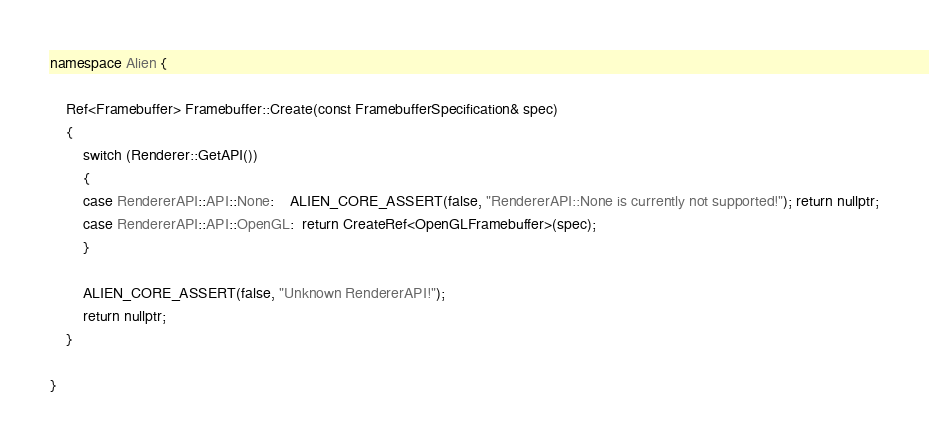Convert code to text. <code><loc_0><loc_0><loc_500><loc_500><_C++_>namespace Alien {

	Ref<Framebuffer> Framebuffer::Create(const FramebufferSpecification& spec)
	{
		switch (Renderer::GetAPI())
		{
		case RendererAPI::API::None:    ALIEN_CORE_ASSERT(false, "RendererAPI::None is currently not supported!"); return nullptr;
		case RendererAPI::API::OpenGL:  return CreateRef<OpenGLFramebuffer>(spec);
		}

		ALIEN_CORE_ASSERT(false, "Unknown RendererAPI!");
		return nullptr;
	}

}

</code> 